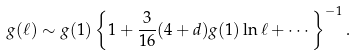<formula> <loc_0><loc_0><loc_500><loc_500>g ( \ell ) \sim g ( 1 ) \left \{ 1 + \frac { 3 } { 1 6 } ( 4 + d ) g ( 1 ) \ln \ell + \cdots \right \} ^ { - 1 } .</formula> 